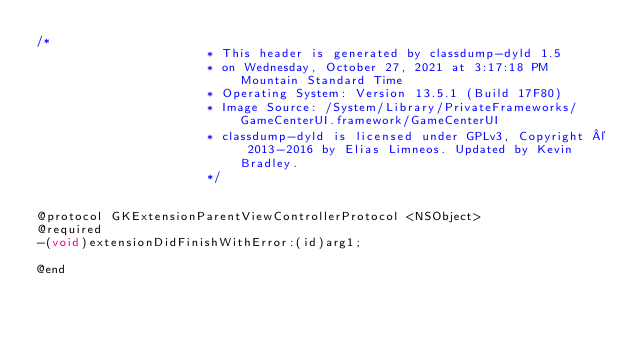Convert code to text. <code><loc_0><loc_0><loc_500><loc_500><_C_>/*
                       * This header is generated by classdump-dyld 1.5
                       * on Wednesday, October 27, 2021 at 3:17:18 PM Mountain Standard Time
                       * Operating System: Version 13.5.1 (Build 17F80)
                       * Image Source: /System/Library/PrivateFrameworks/GameCenterUI.framework/GameCenterUI
                       * classdump-dyld is licensed under GPLv3, Copyright © 2013-2016 by Elias Limneos. Updated by Kevin Bradley.
                       */


@protocol GKExtensionParentViewControllerProtocol <NSObject>
@required
-(void)extensionDidFinishWithError:(id)arg1;

@end

</code> 